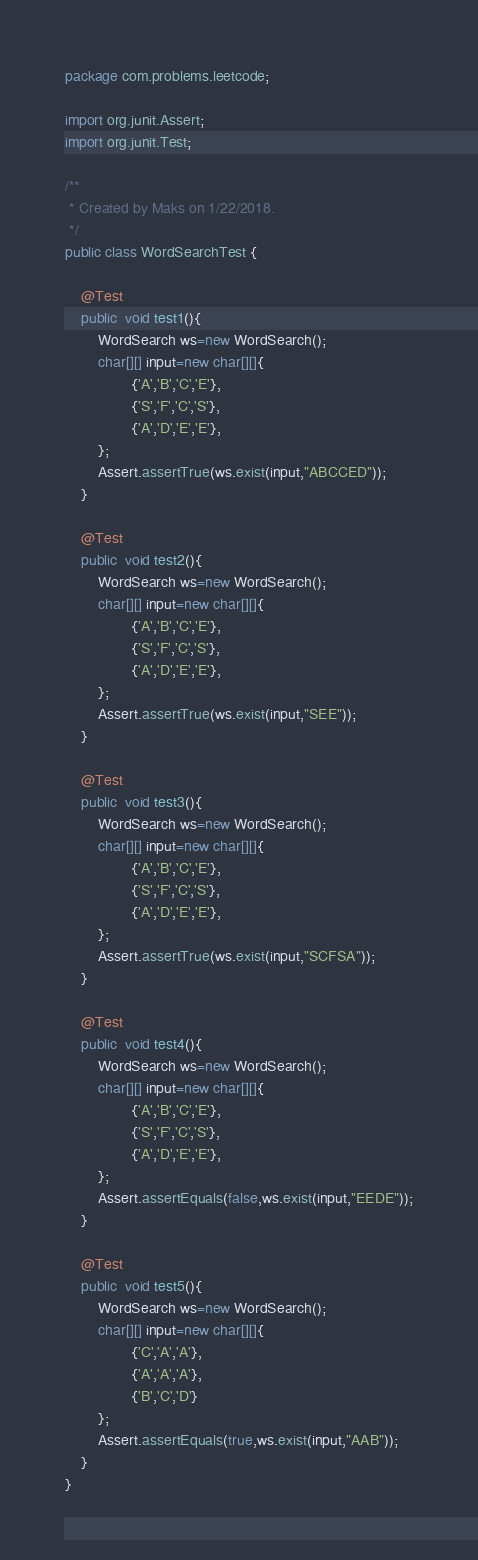<code> <loc_0><loc_0><loc_500><loc_500><_Java_>package com.problems.leetcode;

import org.junit.Assert;
import org.junit.Test;

/**
 * Created by Maks on 1/22/2018.
 */
public class WordSearchTest {

    @Test
    public  void test1(){
        WordSearch ws=new WordSearch();
        char[][] input=new char[][]{
                {'A','B','C','E'},
                {'S','F','C','S'},
                {'A','D','E','E'},
        };
        Assert.assertTrue(ws.exist(input,"ABCCED"));
    }

    @Test
    public  void test2(){
        WordSearch ws=new WordSearch();
        char[][] input=new char[][]{
                {'A','B','C','E'},
                {'S','F','C','S'},
                {'A','D','E','E'},
        };
        Assert.assertTrue(ws.exist(input,"SEE"));
    }

    @Test
    public  void test3(){
        WordSearch ws=new WordSearch();
        char[][] input=new char[][]{
                {'A','B','C','E'},
                {'S','F','C','S'},
                {'A','D','E','E'},
        };
        Assert.assertTrue(ws.exist(input,"SCFSA"));
    }

    @Test
    public  void test4(){
        WordSearch ws=new WordSearch();
        char[][] input=new char[][]{
                {'A','B','C','E'},
                {'S','F','C','S'},
                {'A','D','E','E'},
        };
        Assert.assertEquals(false,ws.exist(input,"EEDE"));
    }

    @Test
    public  void test5(){
        WordSearch ws=new WordSearch();
        char[][] input=new char[][]{
                {'C','A','A'},
                {'A','A','A'},
                {'B','C','D'}
        };
        Assert.assertEquals(true,ws.exist(input,"AAB"));
    }
}
</code> 